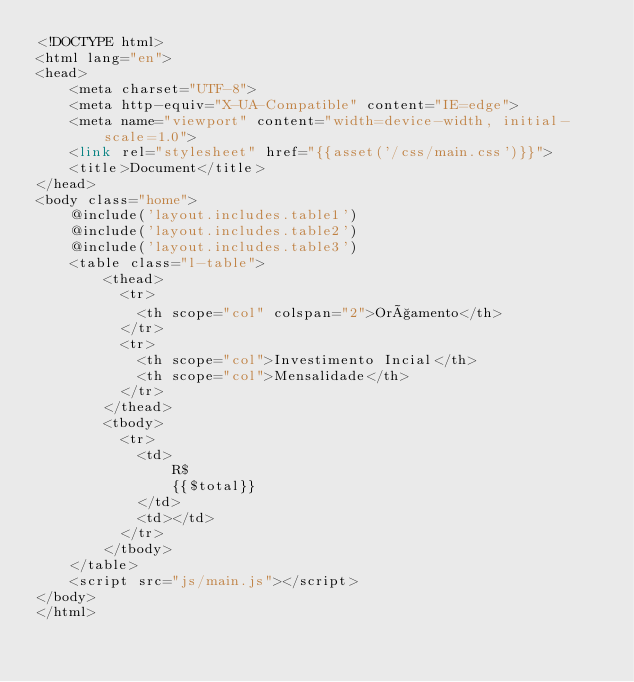Convert code to text. <code><loc_0><loc_0><loc_500><loc_500><_PHP_><!DOCTYPE html>
<html lang="en">
<head>
    <meta charset="UTF-8">
    <meta http-equiv="X-UA-Compatible" content="IE=edge">
    <meta name="viewport" content="width=device-width, initial-scale=1.0">
    <link rel="stylesheet" href="{{asset('/css/main.css')}}">
    <title>Document</title>
</head>
<body class="home">
    @include('layout.includes.table1')
    @include('layout.includes.table2')
    @include('layout.includes.table3')
    <table class="l-table">
        <thead>
          <tr>
            <th scope="col" colspan="2">Orçamento</th>
          </tr>
          <tr>
            <th scope="col">Investimento Incial</th>
            <th scope="col">Mensalidade</th>
          </tr>
        </thead>
        <tbody>
          <tr>
            <td>
                R$
                {{$total}}
            </td>
            <td></td>
          </tr>
        </tbody>
    </table>
    <script src="js/main.js"></script>
</body>
</html>
</code> 